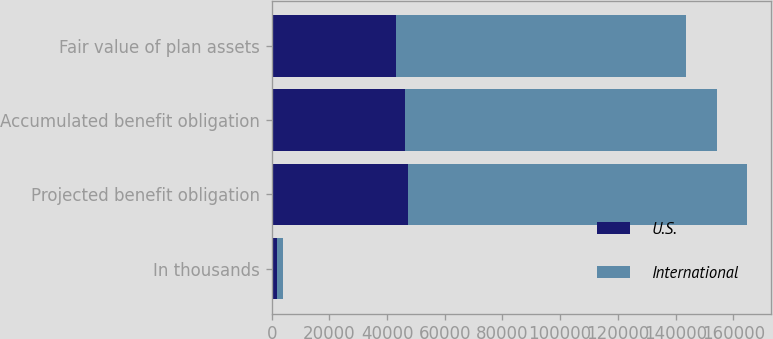Convert chart to OTSL. <chart><loc_0><loc_0><loc_500><loc_500><stacked_bar_chart><ecel><fcel>In thousands<fcel>Projected benefit obligation<fcel>Accumulated benefit obligation<fcel>Fair value of plan assets<nl><fcel>U.S.<fcel>2013<fcel>47090<fcel>46316<fcel>42980<nl><fcel>International<fcel>2013<fcel>117717<fcel>108182<fcel>100798<nl></chart> 